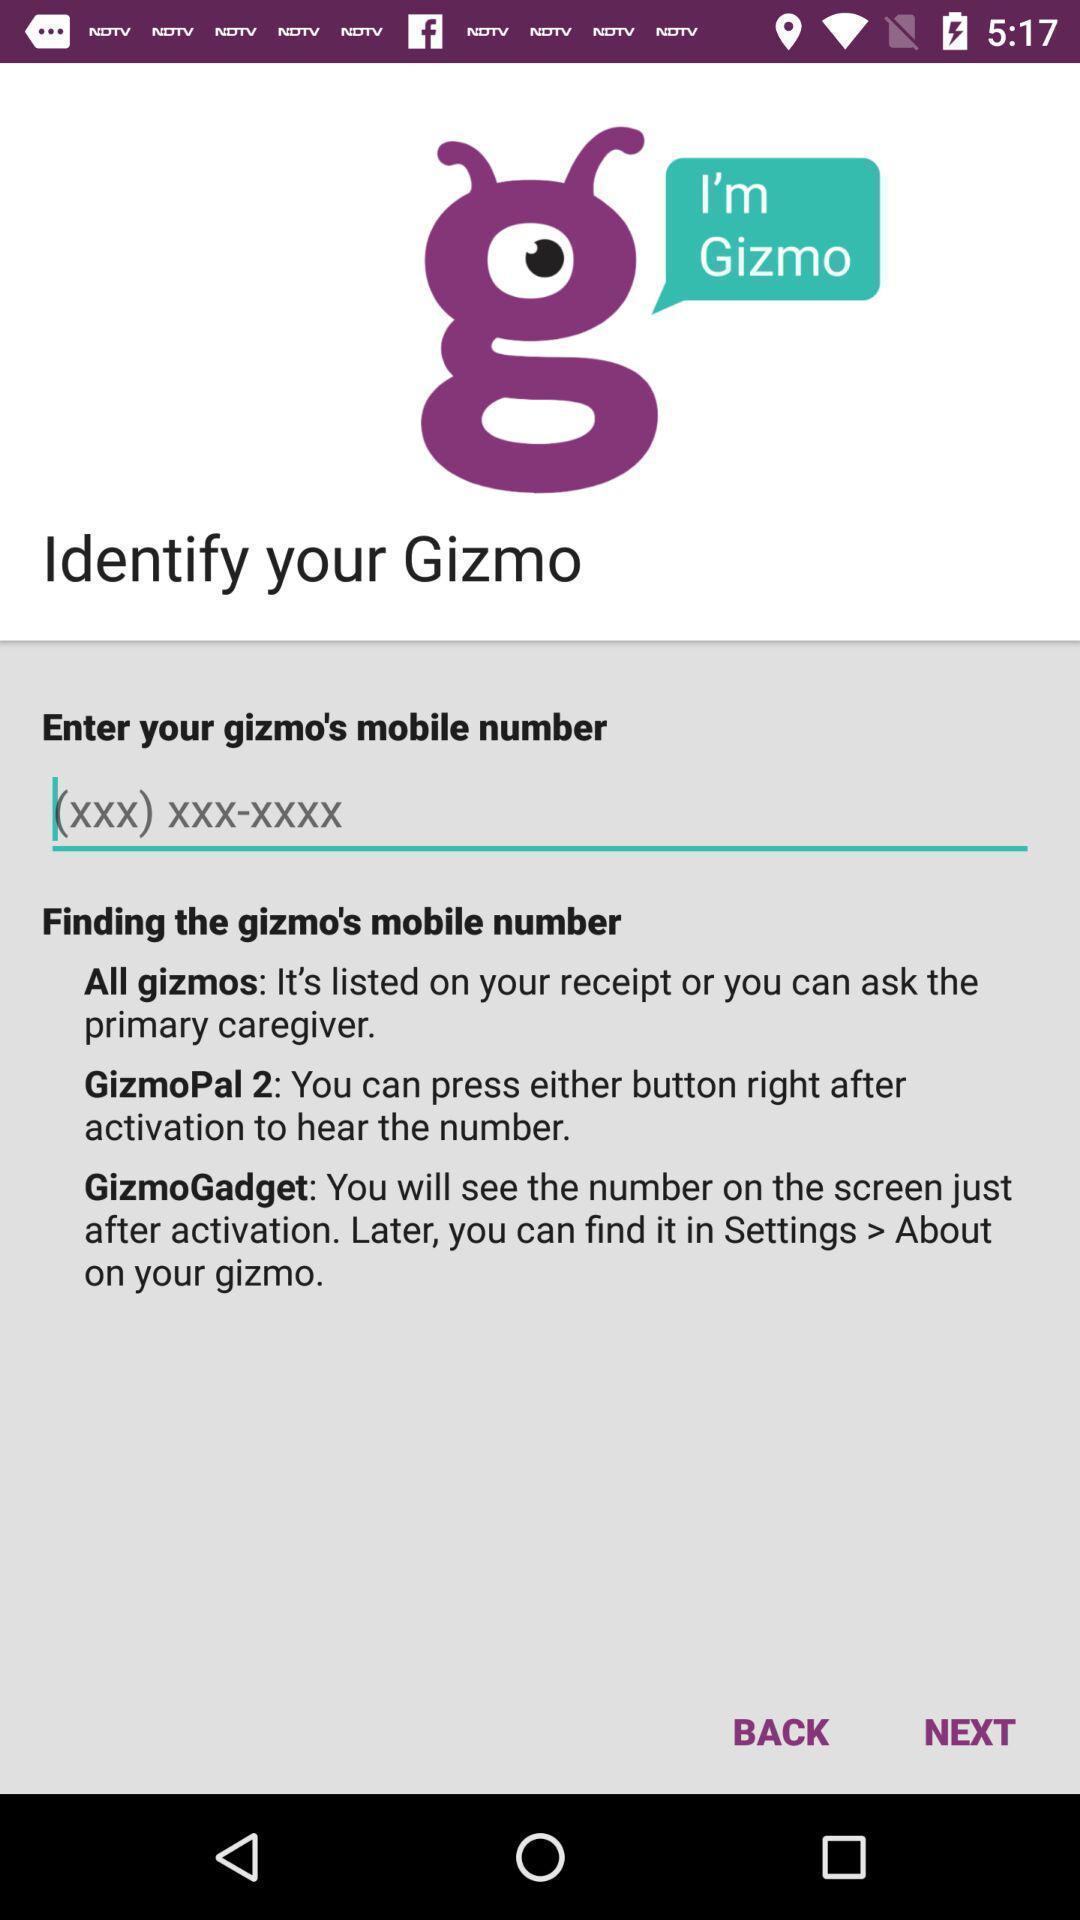Explain the elements present in this screenshot. Page to enter phone number in the call services app. 